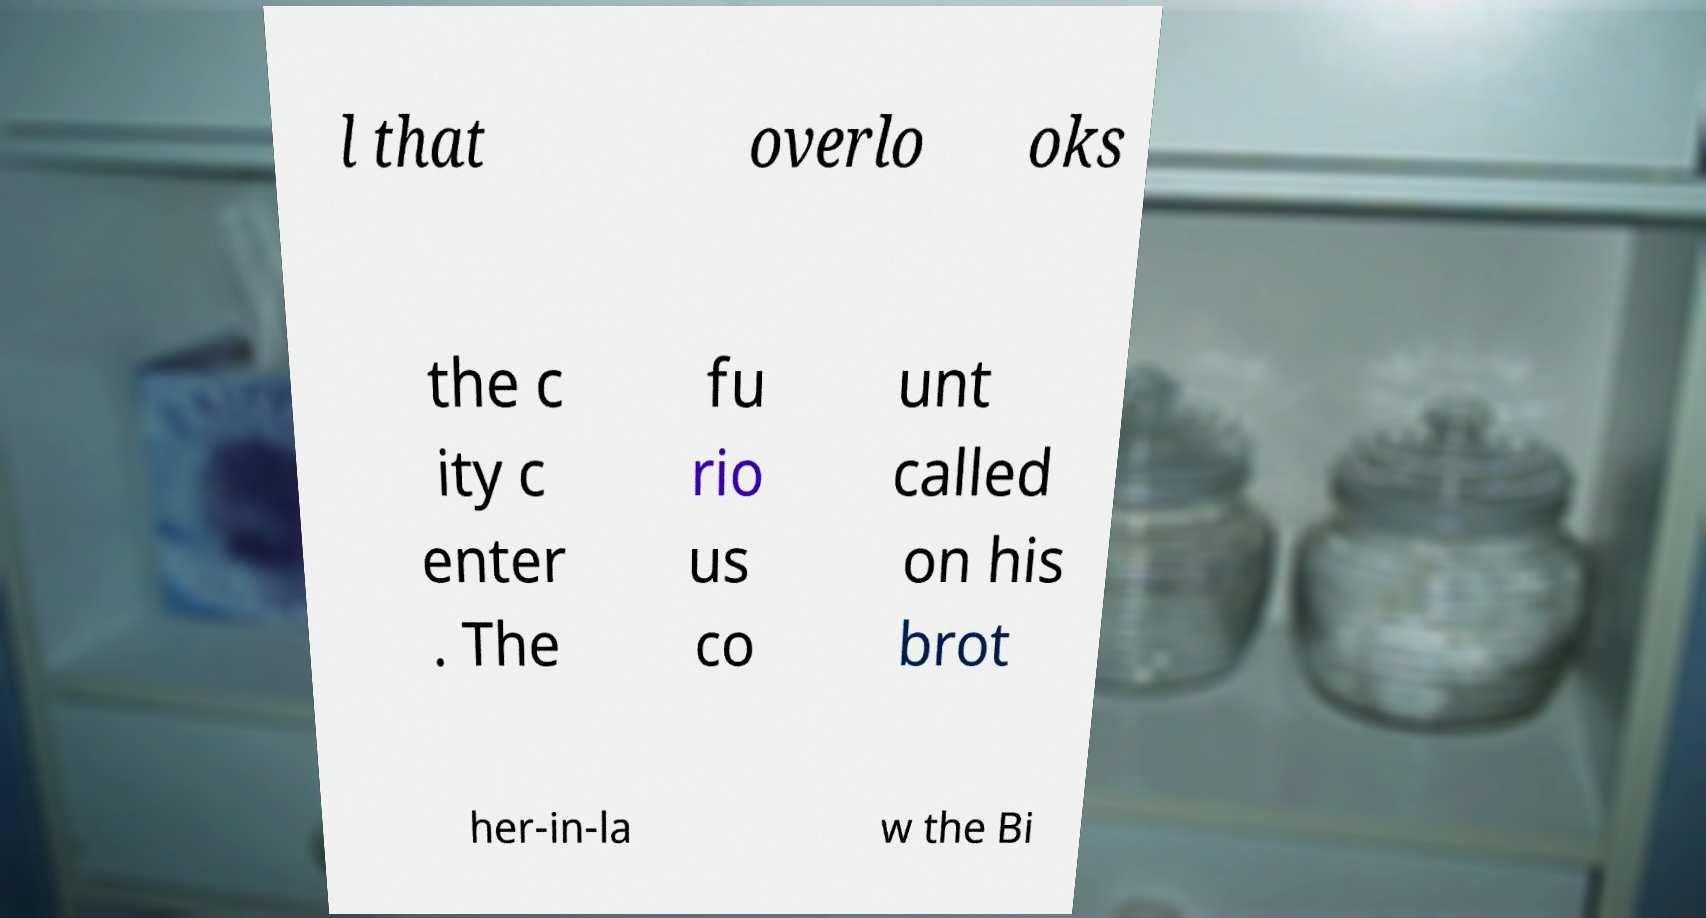What messages or text are displayed in this image? I need them in a readable, typed format. l that overlo oks the c ity c enter . The fu rio us co unt called on his brot her-in-la w the Bi 